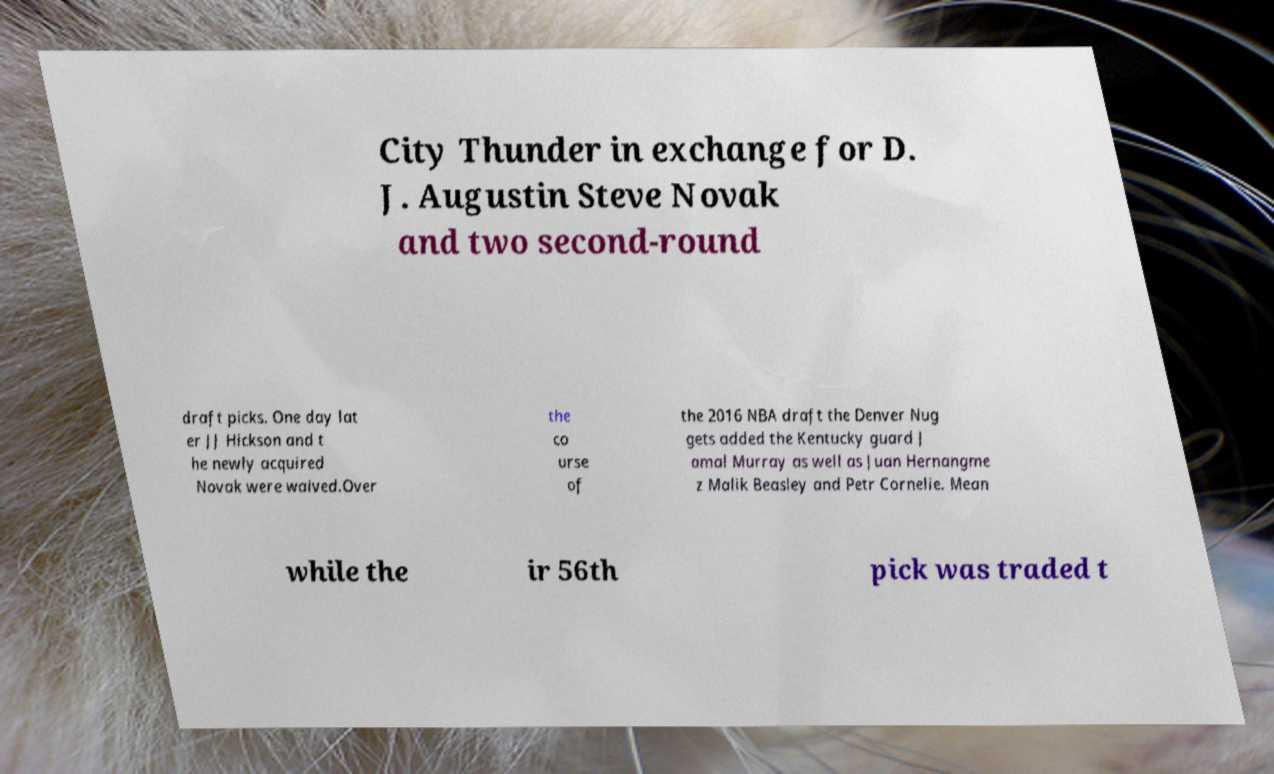What messages or text are displayed in this image? I need them in a readable, typed format. City Thunder in exchange for D. J. Augustin Steve Novak and two second-round draft picks. One day lat er JJ Hickson and t he newly acquired Novak were waived.Over the co urse of the 2016 NBA draft the Denver Nug gets added the Kentucky guard J amal Murray as well as Juan Hernangme z Malik Beasley and Petr Cornelie. Mean while the ir 56th pick was traded t 